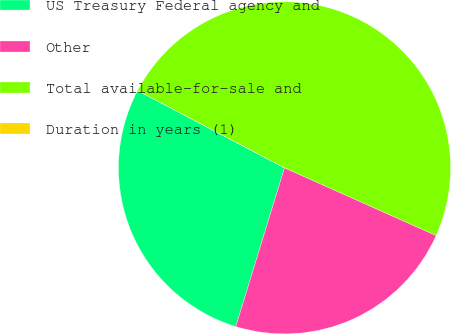<chart> <loc_0><loc_0><loc_500><loc_500><pie_chart><fcel>US Treasury Federal agency and<fcel>Other<fcel>Total available-for-sale and<fcel>Duration in years (1)<nl><fcel>27.96%<fcel>23.06%<fcel>48.98%<fcel>0.0%<nl></chart> 